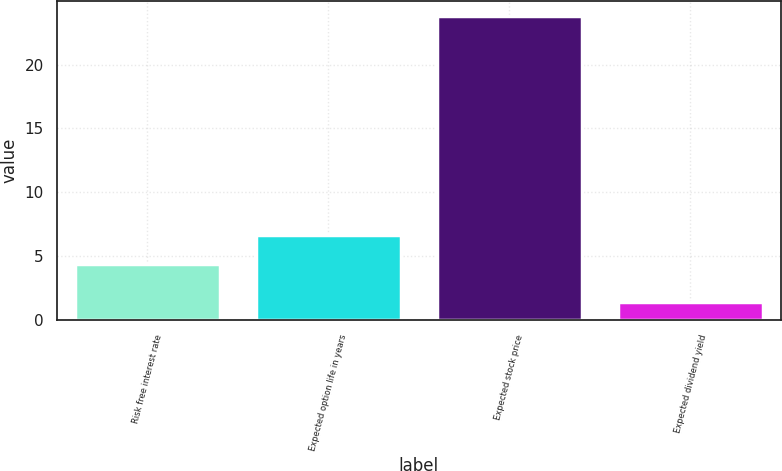Convert chart. <chart><loc_0><loc_0><loc_500><loc_500><bar_chart><fcel>Risk free interest rate<fcel>Expected option life in years<fcel>Expected stock price<fcel>Expected dividend yield<nl><fcel>4.4<fcel>6.64<fcel>23.8<fcel>1.4<nl></chart> 